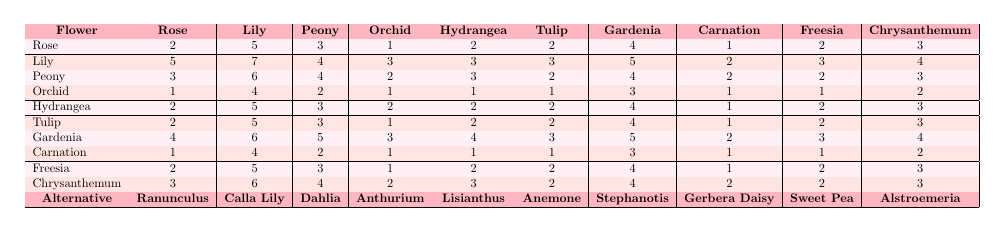What is the allergy rating for Roses? The table shows the allergy ratings in the first row under "Rose." The values are (2, 5, 3, 1, 2, 2, 4, 1, 2, 3).
Answer: 2, 5, 3, 1, 2, 2, 4, 1, 2, 3 Which flower has the highest allergy rating overall? To find the highest rating, I will compare all the numbers in the table. The highest value seen is 7, which is in the row for "Lily."
Answer: Lily What is the average allergy rating of the Tulip? The ratings for Tulip are (2, 5, 3, 1, 2, 2, 4, 1, 2, 3). I will sum these values: 2 + 5 + 3 + 1 + 2 + 2 + 4 + 1 + 2 + 3 = 25. There are 10 ratings, so the average is 25 / 10 = 2.5.
Answer: 2.5 Do any flowers have an allergy rating of 0? By looking through the entire table, I see that no flower has an allergy rating of 0.
Answer: No What is the difference in the allergy rating for Gardenia and its highest alternative? The highest allergy rating for Gardenia is 6, whereas the highest alternative rating for the same column is 5 for "Calla Lily." The difference is 6 - 5 = 1.
Answer: 1 Which flower has the lowest allergy rating among the alternatives? The table shows the ratings for alternatives in the last row. The lowest rating is found to be 1, corresponding to "Gerbera Daisy" and "Sweet Pea."
Answer: Gerbera Daisy and Sweet Pea If I choose a Peony instead of a Lily, what is the difference in their highest allergy ratings? The highest allergy rating for Peony is 6, while for Lily it is 7. The difference is 7 - 6 = 1.
Answer: 1 Which flower has a lower average allergy rating: Tulip or Chrysanthemum? The average rating for Tulip is 2.5 and for Chrysanthemum, it is 2.6. Since 2.5 < 2.6, Tulip has a lower average.
Answer: Tulip What is the total sum of allergy ratings for Orchid? The ratings for Orchid are (1, 4, 2, 1, 1, 1, 3, 1, 1, 2). I will sum these: 1 + 4 + 2 + 1 + 1 + 1 + 3 + 1 + 1 + 2 = 17.
Answer: 17 Is there any flower whose highest allergy rating reaches 6 or higher? By inspecting the table, both Lily and Gardenia have ratings greater than or equal to 6, as their highest is 7 and 6, respectively.
Answer: Yes 